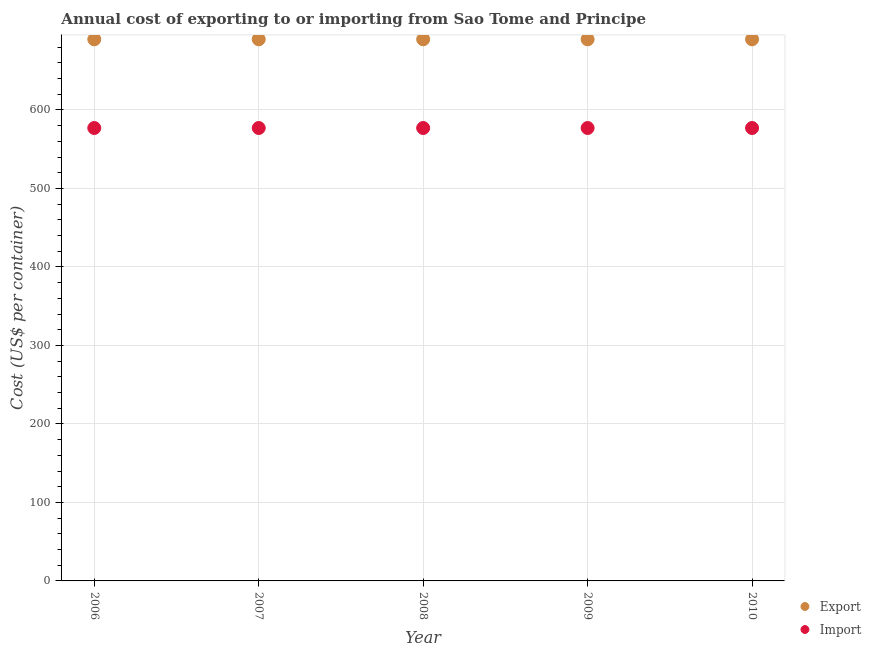What is the export cost in 2008?
Keep it short and to the point. 690. Across all years, what is the maximum import cost?
Ensure brevity in your answer.  577. Across all years, what is the minimum export cost?
Ensure brevity in your answer.  690. In which year was the export cost minimum?
Your response must be concise. 2006. What is the total import cost in the graph?
Keep it short and to the point. 2885. What is the difference between the import cost in 2009 and the export cost in 2008?
Make the answer very short. -113. What is the average import cost per year?
Keep it short and to the point. 577. In the year 2006, what is the difference between the export cost and import cost?
Keep it short and to the point. 113. Is the import cost in 2006 less than that in 2008?
Give a very brief answer. No. Is the difference between the import cost in 2009 and 2010 greater than the difference between the export cost in 2009 and 2010?
Give a very brief answer. No. What is the difference between the highest and the lowest import cost?
Give a very brief answer. 0. Is the export cost strictly greater than the import cost over the years?
Provide a succinct answer. Yes. How many dotlines are there?
Ensure brevity in your answer.  2. What is the difference between two consecutive major ticks on the Y-axis?
Your answer should be compact. 100. Where does the legend appear in the graph?
Offer a terse response. Bottom right. How are the legend labels stacked?
Your response must be concise. Vertical. What is the title of the graph?
Offer a terse response. Annual cost of exporting to or importing from Sao Tome and Principe. Does "GDP" appear as one of the legend labels in the graph?
Provide a succinct answer. No. What is the label or title of the X-axis?
Make the answer very short. Year. What is the label or title of the Y-axis?
Ensure brevity in your answer.  Cost (US$ per container). What is the Cost (US$ per container) of Export in 2006?
Offer a very short reply. 690. What is the Cost (US$ per container) of Import in 2006?
Make the answer very short. 577. What is the Cost (US$ per container) of Export in 2007?
Your response must be concise. 690. What is the Cost (US$ per container) of Import in 2007?
Provide a short and direct response. 577. What is the Cost (US$ per container) in Export in 2008?
Provide a succinct answer. 690. What is the Cost (US$ per container) of Import in 2008?
Your response must be concise. 577. What is the Cost (US$ per container) of Export in 2009?
Your answer should be compact. 690. What is the Cost (US$ per container) of Import in 2009?
Give a very brief answer. 577. What is the Cost (US$ per container) of Export in 2010?
Offer a terse response. 690. What is the Cost (US$ per container) in Import in 2010?
Keep it short and to the point. 577. Across all years, what is the maximum Cost (US$ per container) of Export?
Offer a terse response. 690. Across all years, what is the maximum Cost (US$ per container) of Import?
Your response must be concise. 577. Across all years, what is the minimum Cost (US$ per container) in Export?
Your response must be concise. 690. Across all years, what is the minimum Cost (US$ per container) of Import?
Make the answer very short. 577. What is the total Cost (US$ per container) of Export in the graph?
Give a very brief answer. 3450. What is the total Cost (US$ per container) in Import in the graph?
Keep it short and to the point. 2885. What is the difference between the Cost (US$ per container) of Export in 2006 and that in 2007?
Provide a succinct answer. 0. What is the difference between the Cost (US$ per container) in Export in 2006 and that in 2008?
Provide a short and direct response. 0. What is the difference between the Cost (US$ per container) of Import in 2006 and that in 2008?
Offer a terse response. 0. What is the difference between the Cost (US$ per container) of Import in 2006 and that in 2009?
Give a very brief answer. 0. What is the difference between the Cost (US$ per container) in Export in 2006 and that in 2010?
Offer a terse response. 0. What is the difference between the Cost (US$ per container) in Import in 2007 and that in 2009?
Provide a short and direct response. 0. What is the difference between the Cost (US$ per container) in Export in 2008 and that in 2010?
Ensure brevity in your answer.  0. What is the difference between the Cost (US$ per container) in Import in 2008 and that in 2010?
Keep it short and to the point. 0. What is the difference between the Cost (US$ per container) of Export in 2006 and the Cost (US$ per container) of Import in 2007?
Keep it short and to the point. 113. What is the difference between the Cost (US$ per container) of Export in 2006 and the Cost (US$ per container) of Import in 2008?
Offer a very short reply. 113. What is the difference between the Cost (US$ per container) in Export in 2006 and the Cost (US$ per container) in Import in 2009?
Ensure brevity in your answer.  113. What is the difference between the Cost (US$ per container) in Export in 2006 and the Cost (US$ per container) in Import in 2010?
Provide a succinct answer. 113. What is the difference between the Cost (US$ per container) of Export in 2007 and the Cost (US$ per container) of Import in 2008?
Provide a succinct answer. 113. What is the difference between the Cost (US$ per container) in Export in 2007 and the Cost (US$ per container) in Import in 2009?
Provide a succinct answer. 113. What is the difference between the Cost (US$ per container) of Export in 2007 and the Cost (US$ per container) of Import in 2010?
Keep it short and to the point. 113. What is the difference between the Cost (US$ per container) in Export in 2008 and the Cost (US$ per container) in Import in 2009?
Provide a succinct answer. 113. What is the difference between the Cost (US$ per container) of Export in 2008 and the Cost (US$ per container) of Import in 2010?
Ensure brevity in your answer.  113. What is the difference between the Cost (US$ per container) in Export in 2009 and the Cost (US$ per container) in Import in 2010?
Give a very brief answer. 113. What is the average Cost (US$ per container) in Export per year?
Your answer should be very brief. 690. What is the average Cost (US$ per container) of Import per year?
Provide a short and direct response. 577. In the year 2006, what is the difference between the Cost (US$ per container) in Export and Cost (US$ per container) in Import?
Your answer should be very brief. 113. In the year 2007, what is the difference between the Cost (US$ per container) in Export and Cost (US$ per container) in Import?
Provide a succinct answer. 113. In the year 2008, what is the difference between the Cost (US$ per container) of Export and Cost (US$ per container) of Import?
Your answer should be compact. 113. In the year 2009, what is the difference between the Cost (US$ per container) of Export and Cost (US$ per container) of Import?
Ensure brevity in your answer.  113. In the year 2010, what is the difference between the Cost (US$ per container) of Export and Cost (US$ per container) of Import?
Your answer should be compact. 113. What is the ratio of the Cost (US$ per container) in Export in 2006 to that in 2007?
Offer a very short reply. 1. What is the ratio of the Cost (US$ per container) in Import in 2006 to that in 2007?
Give a very brief answer. 1. What is the ratio of the Cost (US$ per container) in Export in 2006 to that in 2008?
Offer a very short reply. 1. What is the ratio of the Cost (US$ per container) in Import in 2006 to that in 2008?
Provide a succinct answer. 1. What is the ratio of the Cost (US$ per container) of Export in 2006 to that in 2009?
Your response must be concise. 1. What is the ratio of the Cost (US$ per container) of Import in 2006 to that in 2009?
Provide a succinct answer. 1. What is the ratio of the Cost (US$ per container) in Export in 2006 to that in 2010?
Offer a very short reply. 1. What is the ratio of the Cost (US$ per container) in Import in 2006 to that in 2010?
Provide a short and direct response. 1. What is the ratio of the Cost (US$ per container) in Export in 2007 to that in 2009?
Your answer should be compact. 1. What is the ratio of the Cost (US$ per container) of Import in 2007 to that in 2009?
Offer a very short reply. 1. What is the ratio of the Cost (US$ per container) in Import in 2007 to that in 2010?
Keep it short and to the point. 1. What is the ratio of the Cost (US$ per container) in Export in 2008 to that in 2009?
Provide a succinct answer. 1. What is the ratio of the Cost (US$ per container) in Import in 2008 to that in 2009?
Your answer should be very brief. 1. What is the ratio of the Cost (US$ per container) in Export in 2008 to that in 2010?
Ensure brevity in your answer.  1. What is the ratio of the Cost (US$ per container) of Export in 2009 to that in 2010?
Offer a terse response. 1. What is the ratio of the Cost (US$ per container) of Import in 2009 to that in 2010?
Make the answer very short. 1. What is the difference between the highest and the second highest Cost (US$ per container) of Export?
Offer a terse response. 0. What is the difference between the highest and the second highest Cost (US$ per container) in Import?
Ensure brevity in your answer.  0. What is the difference between the highest and the lowest Cost (US$ per container) of Export?
Your answer should be very brief. 0. What is the difference between the highest and the lowest Cost (US$ per container) in Import?
Offer a very short reply. 0. 